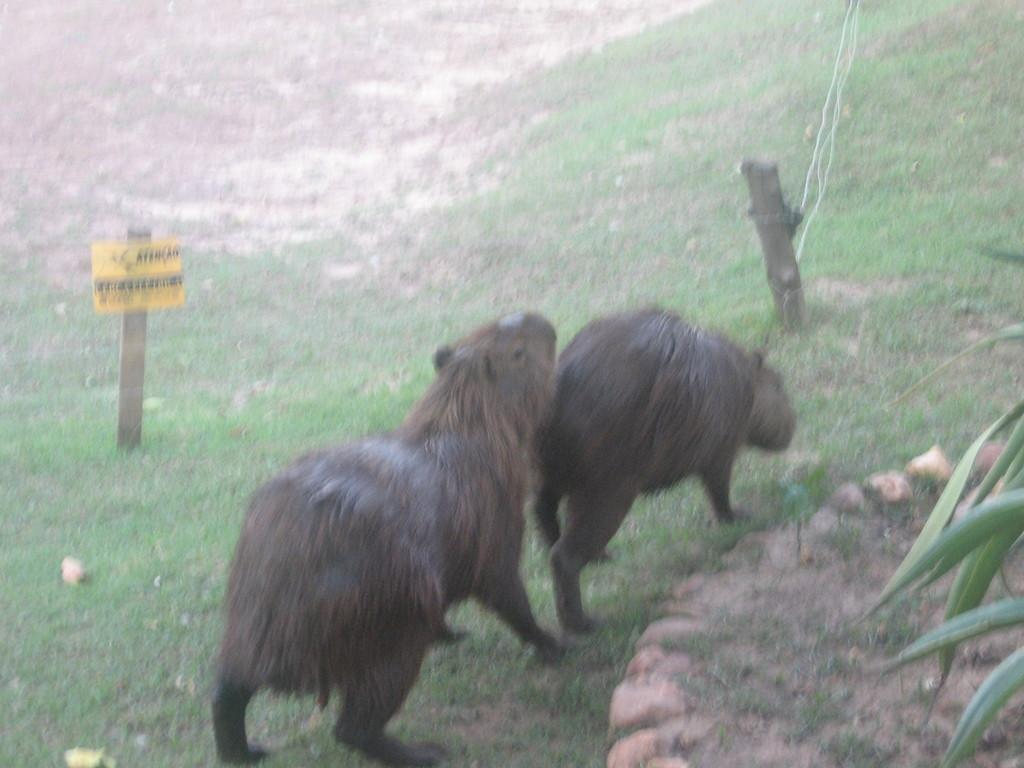What type of animals can be seen in the image? There are two animals visible on the grass. What is located on the left side of the image? There is a signboard on the left side of the image. What can be seen on the right side of the image? There are leaves of trees visible on the right side of the image. What type of grain is being harvested in the image? There is no grain visible in the image; it features two animals on the grass, a signboard on the left side, and leaves of trees on the right side. 